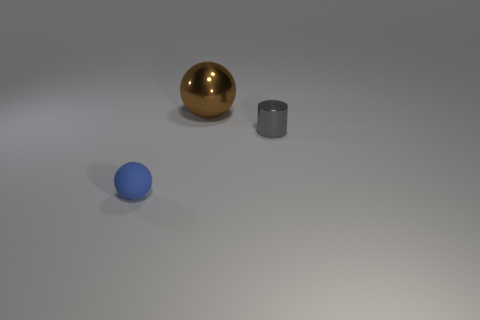What can you infer about the purpose of this image? The image might be a part of a study on shapes, materials, and lighting in a controlled setting, possibly for educational or artistic purposes. It could be used to demonstrate how different surfaces interact with light or to practice rendering techniques in a computer graphics simulation. 